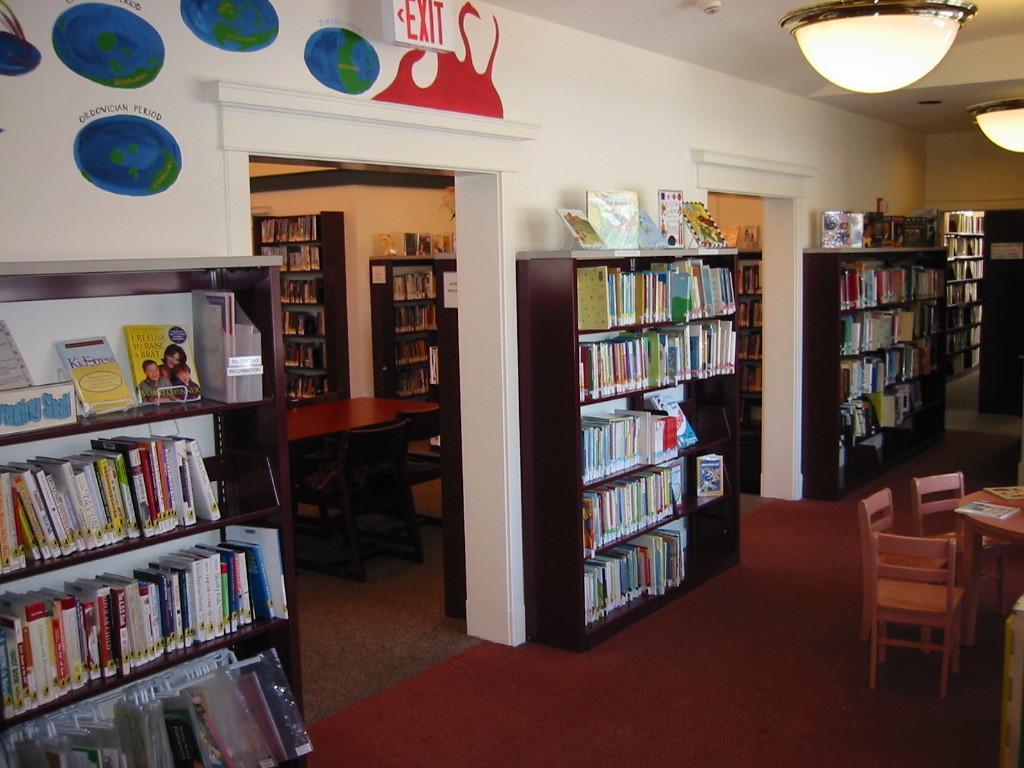Could you give a brief overview of what you see in this image? This is the picture of a library where we have different shelf on which some books are placed and there are some lamps, chairs and tables. 